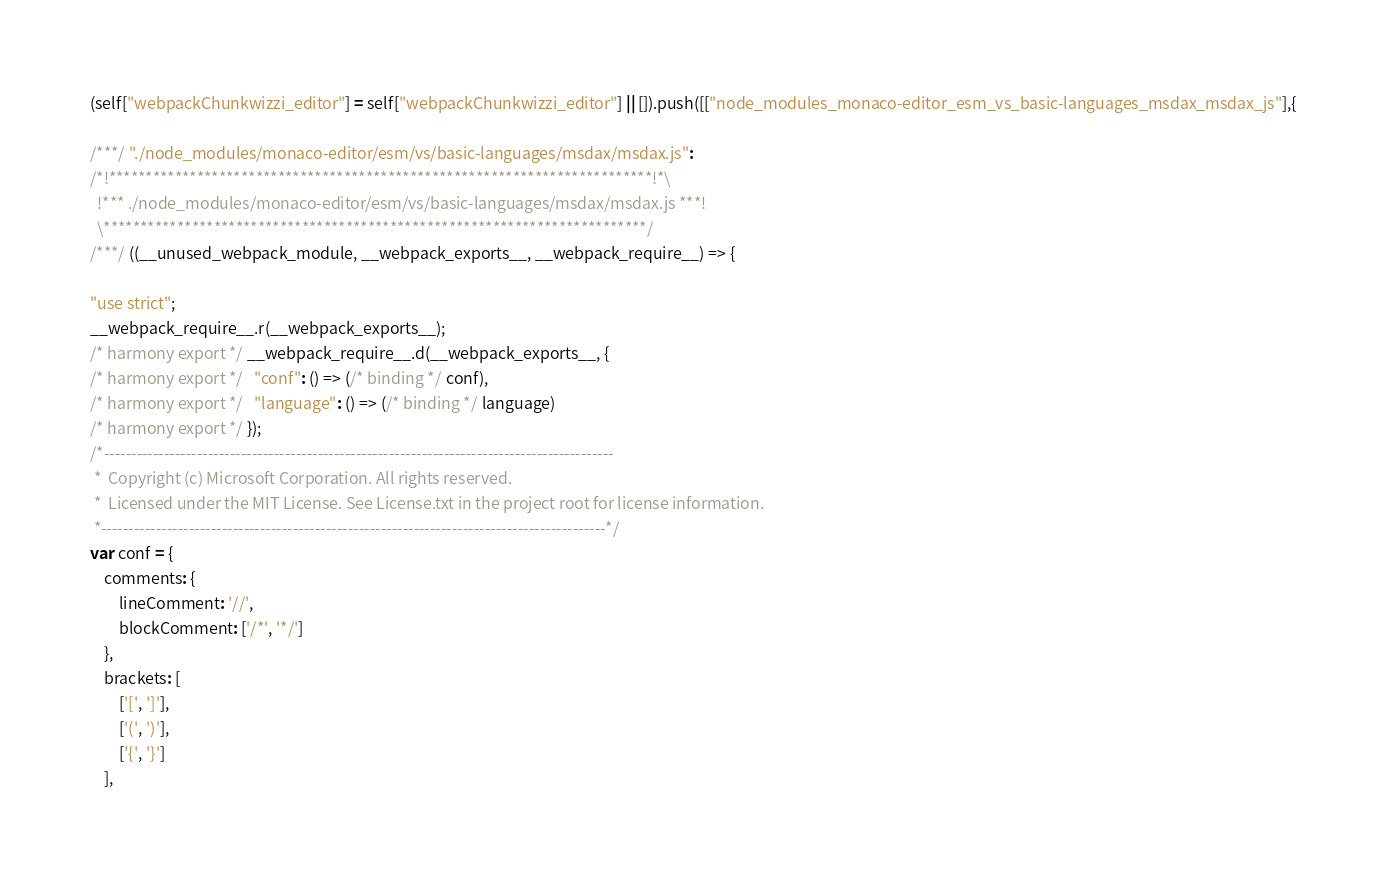Convert code to text. <code><loc_0><loc_0><loc_500><loc_500><_JavaScript_>(self["webpackChunkwizzi_editor"] = self["webpackChunkwizzi_editor"] || []).push([["node_modules_monaco-editor_esm_vs_basic-languages_msdax_msdax_js"],{

/***/ "./node_modules/monaco-editor/esm/vs/basic-languages/msdax/msdax.js":
/*!**************************************************************************!*\
  !*** ./node_modules/monaco-editor/esm/vs/basic-languages/msdax/msdax.js ***!
  \**************************************************************************/
/***/ ((__unused_webpack_module, __webpack_exports__, __webpack_require__) => {

"use strict";
__webpack_require__.r(__webpack_exports__);
/* harmony export */ __webpack_require__.d(__webpack_exports__, {
/* harmony export */   "conf": () => (/* binding */ conf),
/* harmony export */   "language": () => (/* binding */ language)
/* harmony export */ });
/*---------------------------------------------------------------------------------------------
 *  Copyright (c) Microsoft Corporation. All rights reserved.
 *  Licensed under the MIT License. See License.txt in the project root for license information.
 *--------------------------------------------------------------------------------------------*/
var conf = {
    comments: {
        lineComment: '//',
        blockComment: ['/*', '*/']
    },
    brackets: [
        ['[', ']'],
        ['(', ')'],
        ['{', '}']
    ],</code> 